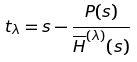Convert formula to latex. <formula><loc_0><loc_0><loc_500><loc_500>t _ { \lambda } = s - \frac { P ( s ) } { \overline { H } ^ { ( \lambda ) } ( s ) }</formula> 